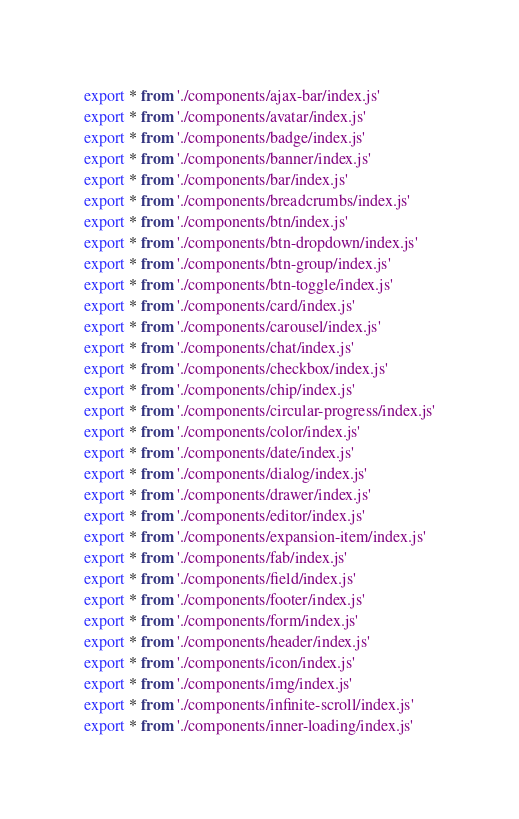Convert code to text. <code><loc_0><loc_0><loc_500><loc_500><_JavaScript_>export * from './components/ajax-bar/index.js'
export * from './components/avatar/index.js'
export * from './components/badge/index.js'
export * from './components/banner/index.js'
export * from './components/bar/index.js'
export * from './components/breadcrumbs/index.js'
export * from './components/btn/index.js'
export * from './components/btn-dropdown/index.js'
export * from './components/btn-group/index.js'
export * from './components/btn-toggle/index.js'
export * from './components/card/index.js'
export * from './components/carousel/index.js'
export * from './components/chat/index.js'
export * from './components/checkbox/index.js'
export * from './components/chip/index.js'
export * from './components/circular-progress/index.js'
export * from './components/color/index.js'
export * from './components/date/index.js'
export * from './components/dialog/index.js'
export * from './components/drawer/index.js'
export * from './components/editor/index.js'
export * from './components/expansion-item/index.js'
export * from './components/fab/index.js'
export * from './components/field/index.js'
export * from './components/footer/index.js'
export * from './components/form/index.js'
export * from './components/header/index.js'
export * from './components/icon/index.js'
export * from './components/img/index.js'
export * from './components/infinite-scroll/index.js'
export * from './components/inner-loading/index.js'</code> 